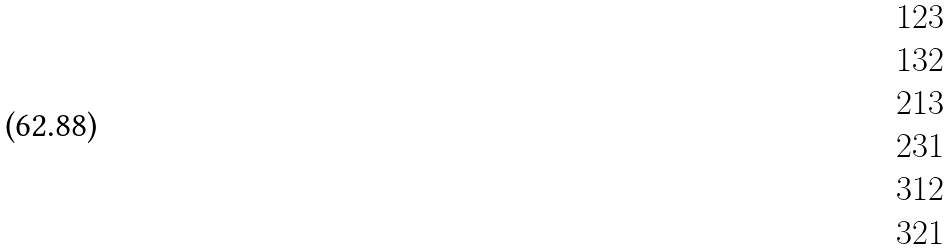Convert formula to latex. <formula><loc_0><loc_0><loc_500><loc_500>\begin{matrix} 1 2 3 \\ 1 3 2 \\ 2 1 3 \\ 2 3 1 \\ 3 1 2 \\ 3 2 1 \\ \end{matrix}</formula> 